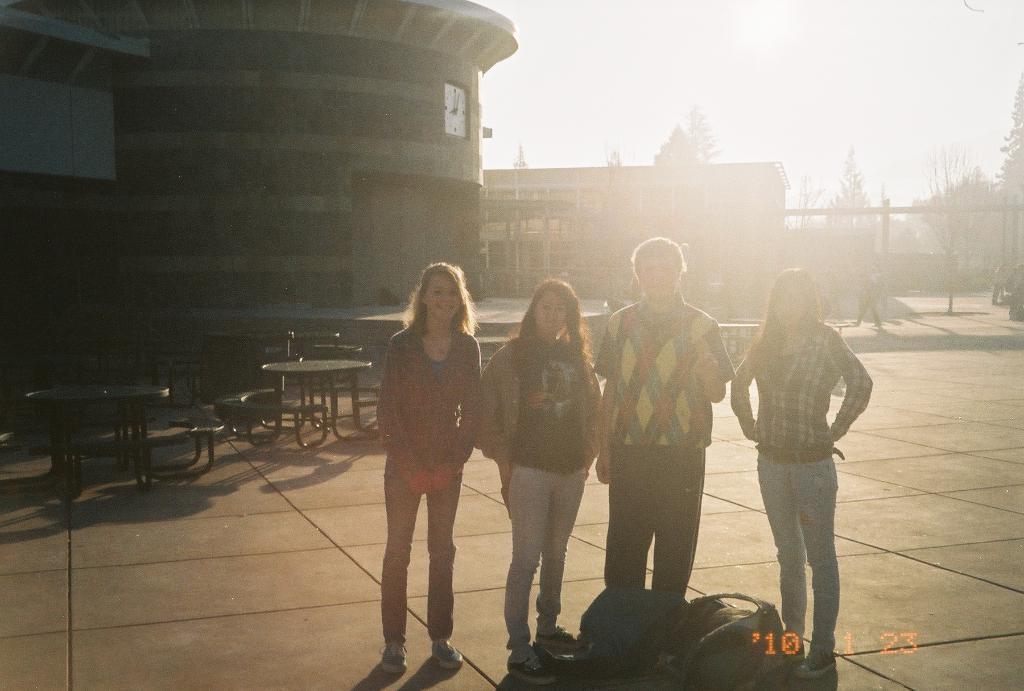Please provide a concise description of this image. There are three women and a man standing. These look like the bags. I can see the tables with the benches. This looks like a wall clock, which is attached to the building wall. In the background, I can see the buildings and the trees. This looks like a watermark on the image. 